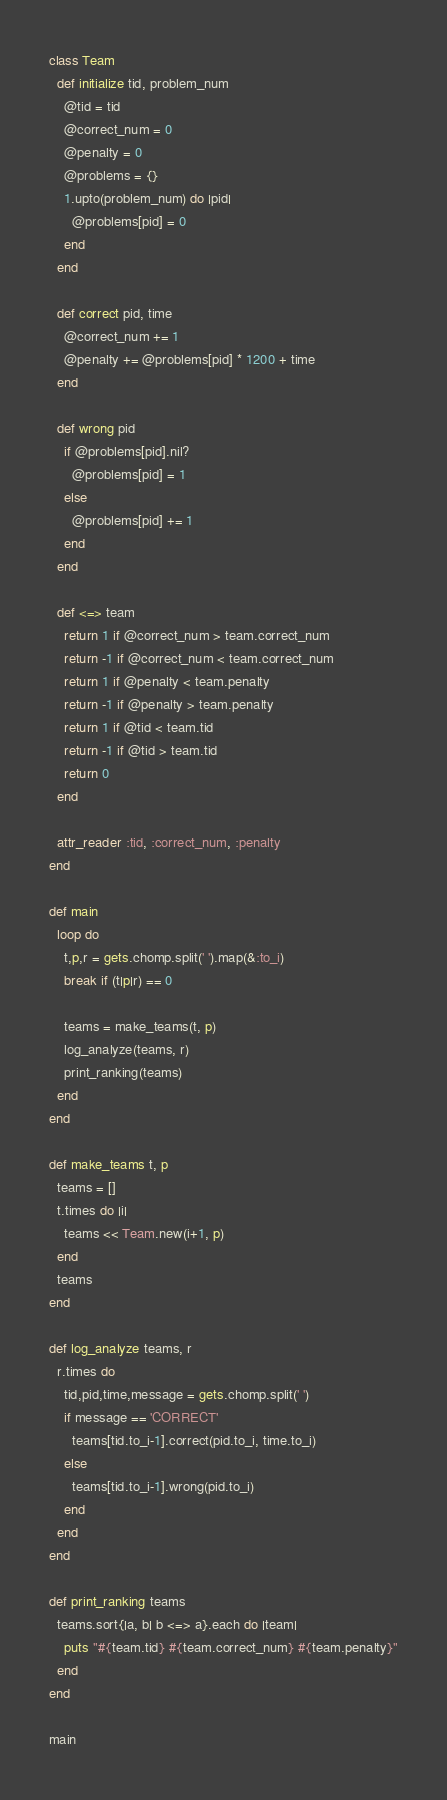Convert code to text. <code><loc_0><loc_0><loc_500><loc_500><_Ruby_>class Team
  def initialize tid, problem_num
    @tid = tid
    @correct_num = 0
    @penalty = 0
    @problems = {}
    1.upto(problem_num) do |pid|
      @problems[pid] = 0
    end
  end

  def correct pid, time
    @correct_num += 1
    @penalty += @problems[pid] * 1200 + time
  end

  def wrong pid
    if @problems[pid].nil?
      @problems[pid] = 1
    else
      @problems[pid] += 1
    end
  end

  def <=> team
    return 1 if @correct_num > team.correct_num
    return -1 if @correct_num < team.correct_num
    return 1 if @penalty < team.penalty
    return -1 if @penalty > team.penalty
    return 1 if @tid < team.tid
    return -1 if @tid > team.tid
    return 0
  end

  attr_reader :tid, :correct_num, :penalty
end

def main
  loop do
    t,p,r = gets.chomp.split(' ').map(&:to_i)
    break if (t|p|r) == 0

    teams = make_teams(t, p)
    log_analyze(teams, r)
    print_ranking(teams)
  end
end

def make_teams t, p
  teams = []
  t.times do |i|
    teams << Team.new(i+1, p)
  end
  teams
end

def log_analyze teams, r
  r.times do
    tid,pid,time,message = gets.chomp.split(' ')
    if message == 'CORRECT'
      teams[tid.to_i-1].correct(pid.to_i, time.to_i)
    else
      teams[tid.to_i-1].wrong(pid.to_i)
    end
  end
end

def print_ranking teams
  teams.sort{|a, b| b <=> a}.each do |team|
    puts "#{team.tid} #{team.correct_num} #{team.penalty}"
  end
end

main</code> 